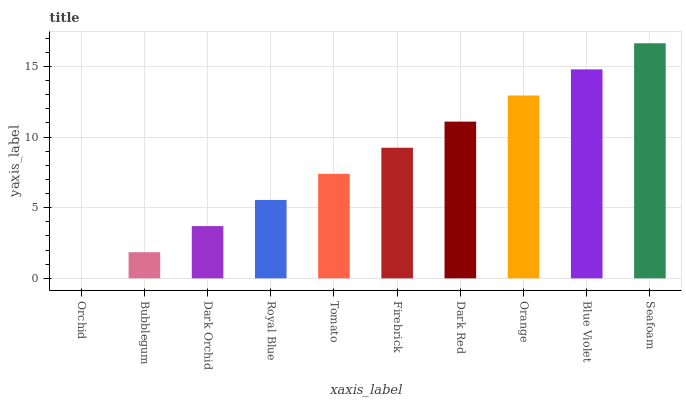Is Orchid the minimum?
Answer yes or no. Yes. Is Seafoam the maximum?
Answer yes or no. Yes. Is Bubblegum the minimum?
Answer yes or no. No. Is Bubblegum the maximum?
Answer yes or no. No. Is Bubblegum greater than Orchid?
Answer yes or no. Yes. Is Orchid less than Bubblegum?
Answer yes or no. Yes. Is Orchid greater than Bubblegum?
Answer yes or no. No. Is Bubblegum less than Orchid?
Answer yes or no. No. Is Firebrick the high median?
Answer yes or no. Yes. Is Tomato the low median?
Answer yes or no. Yes. Is Orange the high median?
Answer yes or no. No. Is Bubblegum the low median?
Answer yes or no. No. 